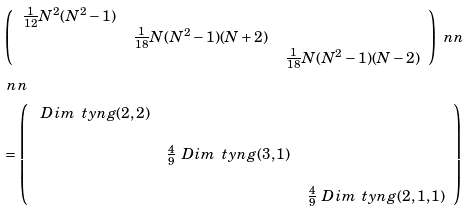<formula> <loc_0><loc_0><loc_500><loc_500>& \left ( \begin{array} { c c c } \frac { 1 } { 1 2 } N ^ { 2 } ( N ^ { 2 } - 1 ) & & \\ & \frac { 1 } { 1 8 } N ( N ^ { 2 } - 1 ) ( N + 2 ) & \\ & & \frac { 1 } { 1 8 } N ( N ^ { 2 } - 1 ) ( N - 2 ) \end{array} \right ) \ n n \\ & \ n n \\ & = \left ( \begin{array} { c c c } \ D i m \, \ t y n g ( 2 , 2 ) & & \\ & & \\ & \frac { 4 } { 9 } \ D i m \, \ t y n g ( 3 , 1 ) & \\ & & \\ & & \frac { 4 } { 9 } \ D i m \, \ t y n g ( 2 , 1 , 1 ) \end{array} \right )</formula> 